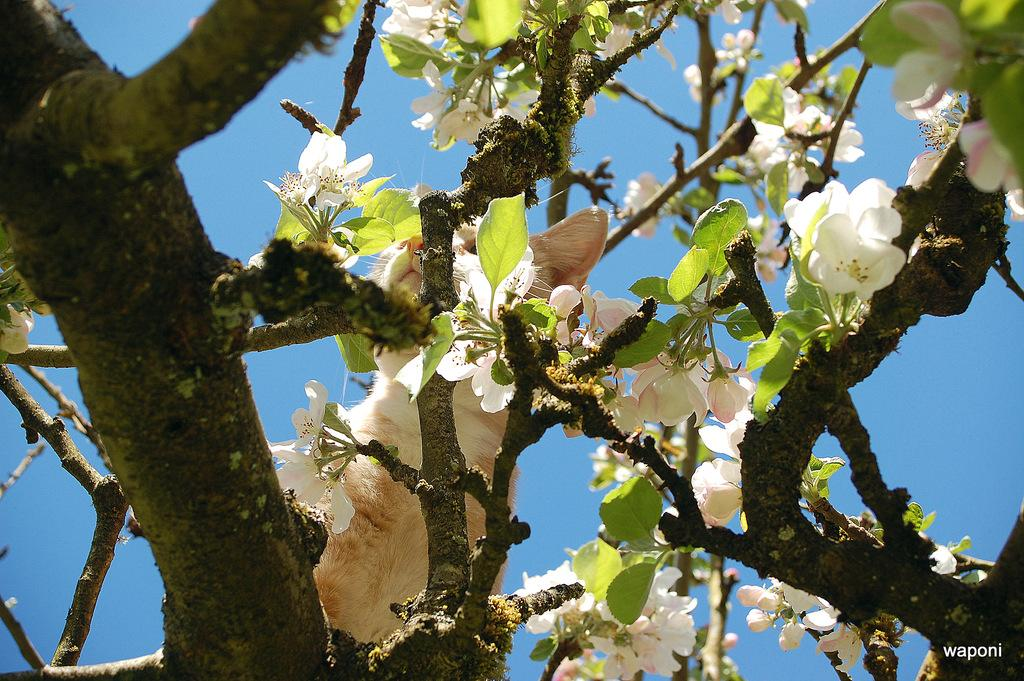What animal is on the tree in the image? There is a cat on a tree in the image. What type of flowers are on the tree? There are white color flowers on the tree. What can be seen in the background of the image? The sky is visible in the background of the image. Is there any additional mark or feature on the image? Yes, there is a watermark in the image. How many crates are stacked next to the tree in the image? There are no crates present in the image. What type of boundary is visible around the tree in the image? There is no boundary visible around the tree in the image. 